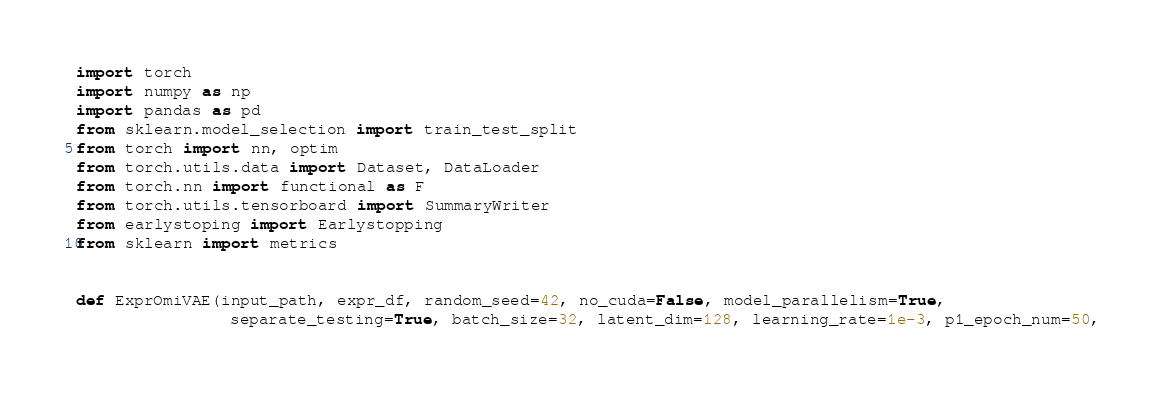Convert code to text. <code><loc_0><loc_0><loc_500><loc_500><_Python_>import torch
import numpy as np
import pandas as pd
from sklearn.model_selection import train_test_split
from torch import nn, optim
from torch.utils.data import Dataset, DataLoader
from torch.nn import functional as F
from torch.utils.tensorboard import SummaryWriter
from earlystoping import Earlystopping
from sklearn import metrics


def ExprOmiVAE(input_path, expr_df, random_seed=42, no_cuda=False, model_parallelism=True,
                separate_testing=True, batch_size=32, latent_dim=128, learning_rate=1e-3, p1_epoch_num=50,</code> 